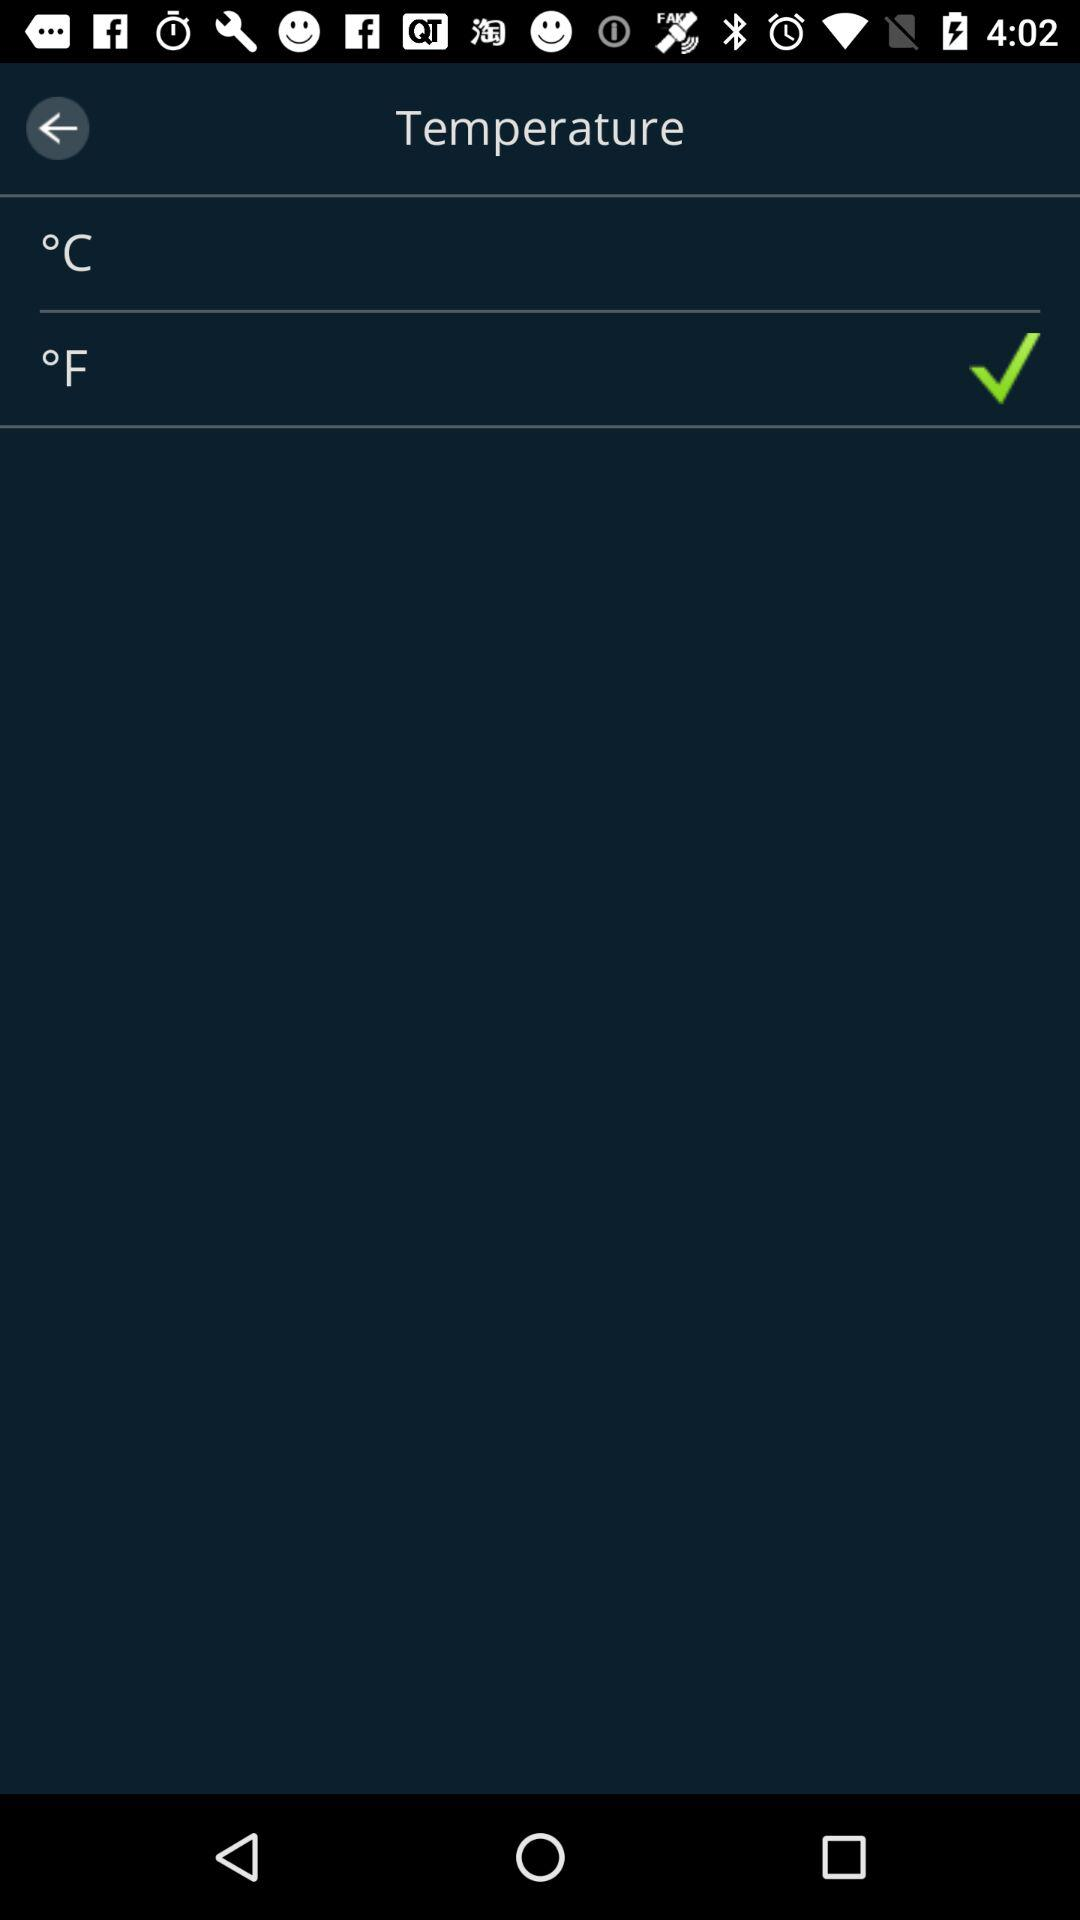What is the selected temperature unit? The selected temperature unit is °F. 